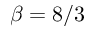Convert formula to latex. <formula><loc_0><loc_0><loc_500><loc_500>\beta = 8 / 3</formula> 